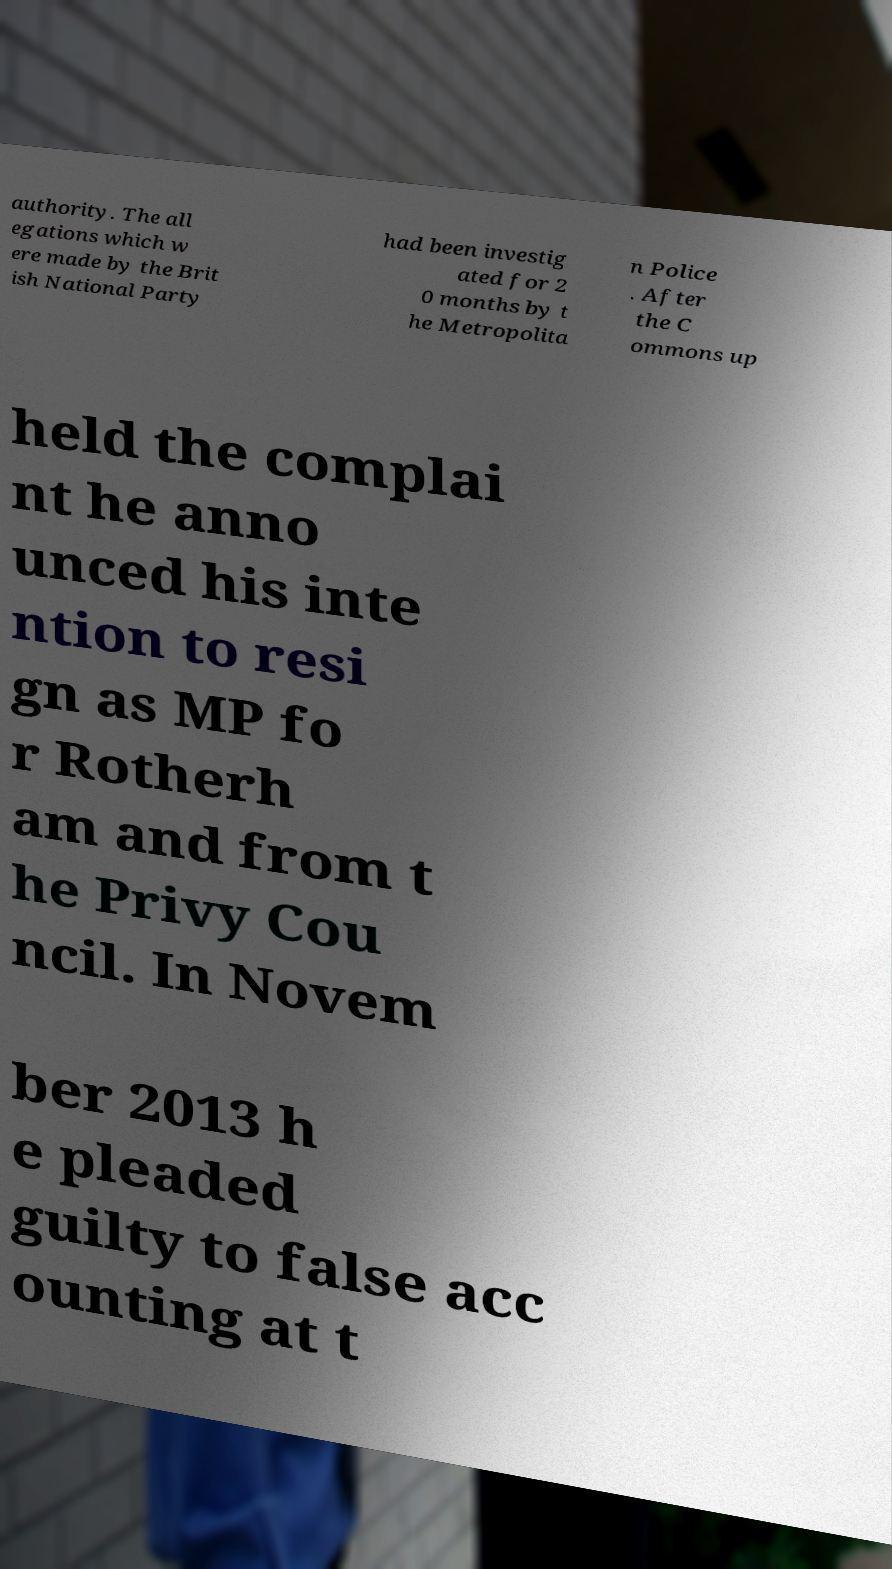Please identify and transcribe the text found in this image. authority. The all egations which w ere made by the Brit ish National Party had been investig ated for 2 0 months by t he Metropolita n Police . After the C ommons up held the complai nt he anno unced his inte ntion to resi gn as MP fo r Rotherh am and from t he Privy Cou ncil. In Novem ber 2013 h e pleaded guilty to false acc ounting at t 